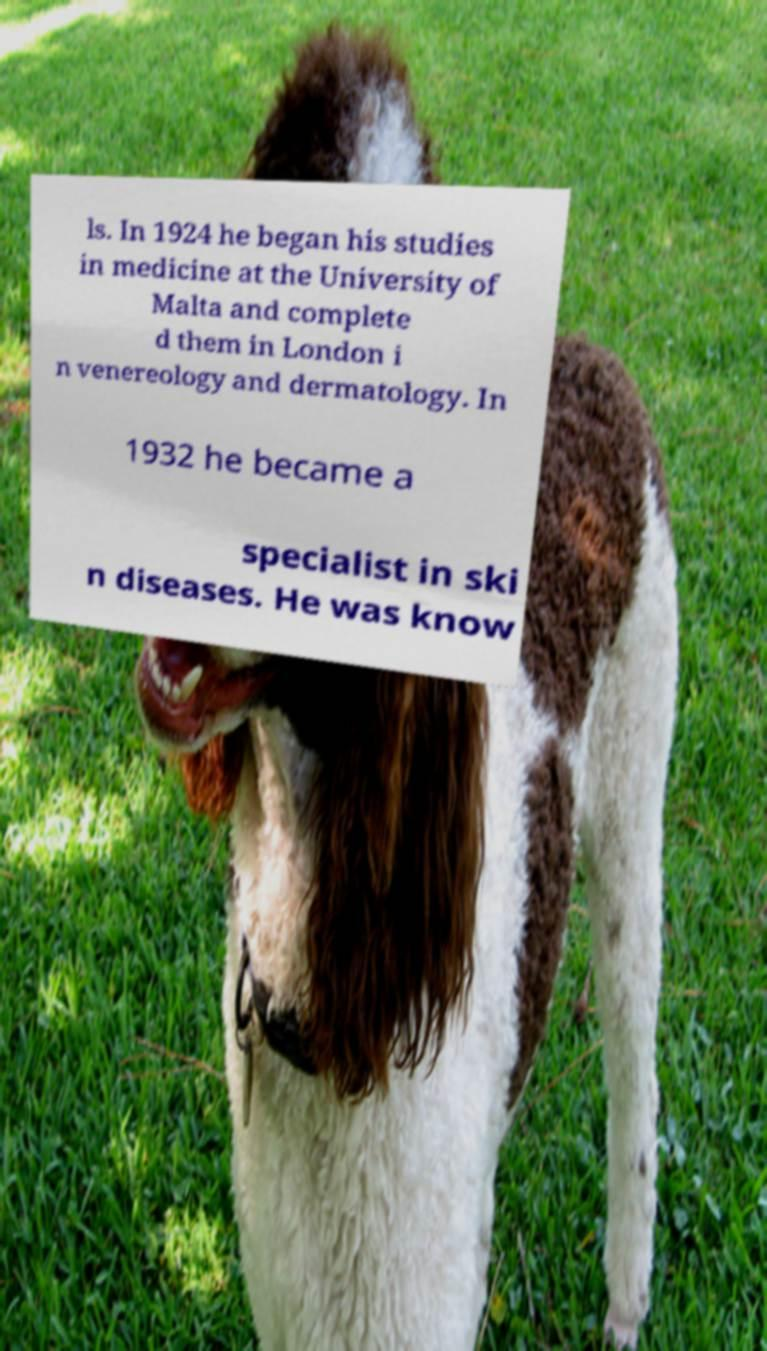Could you assist in decoding the text presented in this image and type it out clearly? ls. In 1924 he began his studies in medicine at the University of Malta and complete d them in London i n venereology and dermatology. In 1932 he became a specialist in ski n diseases. He was know 